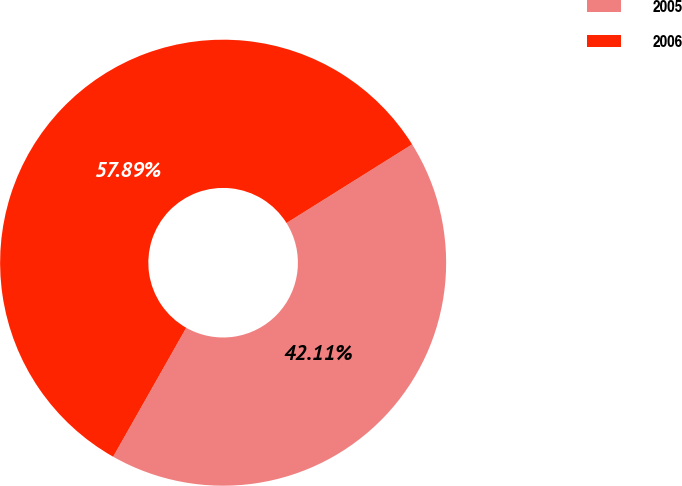<chart> <loc_0><loc_0><loc_500><loc_500><pie_chart><fcel>2005<fcel>2006<nl><fcel>42.11%<fcel>57.89%<nl></chart> 